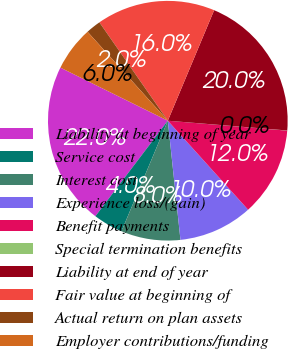Convert chart. <chart><loc_0><loc_0><loc_500><loc_500><pie_chart><fcel>Liability at beginning of year<fcel>Service cost<fcel>Interest cost<fcel>Experience loss/(gain)<fcel>Benefit payments<fcel>Special termination benefits<fcel>Liability at end of year<fcel>Fair value at beginning of<fcel>Actual return on plan assets<fcel>Employer contributions/funding<nl><fcel>21.98%<fcel>4.01%<fcel>8.0%<fcel>10.0%<fcel>12.0%<fcel>0.02%<fcel>19.98%<fcel>15.99%<fcel>2.01%<fcel>6.01%<nl></chart> 